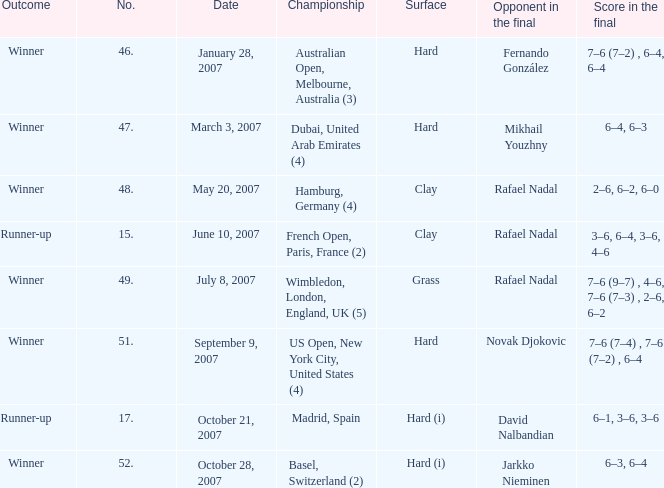Can you give me this table as a dict? {'header': ['Outcome', 'No.', 'Date', 'Championship', 'Surface', 'Opponent in the final', 'Score in the final'], 'rows': [['Winner', '46.', 'January 28, 2007', 'Australian Open, Melbourne, Australia (3)', 'Hard', 'Fernando González', '7–6 (7–2) , 6–4, 6–4'], ['Winner', '47.', 'March 3, 2007', 'Dubai, United Arab Emirates (4)', 'Hard', 'Mikhail Youzhny', '6–4, 6–3'], ['Winner', '48.', 'May 20, 2007', 'Hamburg, Germany (4)', 'Clay', 'Rafael Nadal', '2–6, 6–2, 6–0'], ['Runner-up', '15.', 'June 10, 2007', 'French Open, Paris, France (2)', 'Clay', 'Rafael Nadal', '3–6, 6–4, 3–6, 4–6'], ['Winner', '49.', 'July 8, 2007', 'Wimbledon, London, England, UK (5)', 'Grass', 'Rafael Nadal', '7–6 (9–7) , 4–6, 7–6 (7–3) , 2–6, 6–2'], ['Winner', '51.', 'September 9, 2007', 'US Open, New York City, United States (4)', 'Hard', 'Novak Djokovic', '7–6 (7–4) , 7–6 (7–2) , 6–4'], ['Runner-up', '17.', 'October 21, 2007', 'Madrid, Spain', 'Hard (i)', 'David Nalbandian', '6–1, 3–6, 3–6'], ['Winner', '52.', 'October 28, 2007', 'Basel, Switzerland (2)', 'Hard (i)', 'Jarkko Nieminen', '6–3, 6–4']]} Where the outcome is Winner and surface is Hard (i), what is the No.? 52.0. 